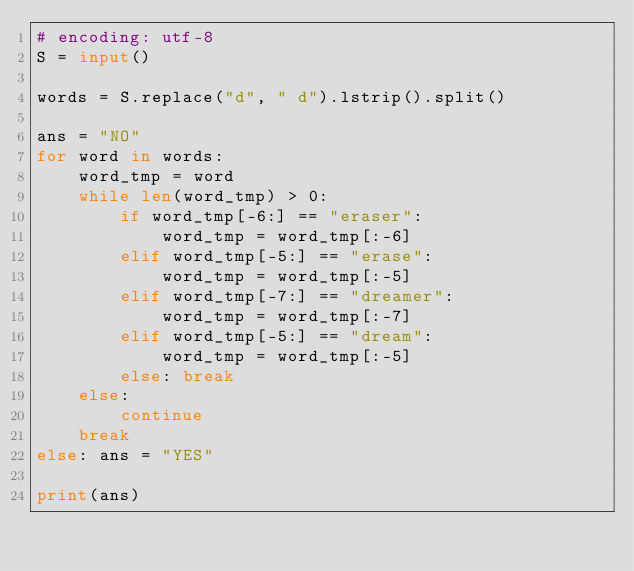Convert code to text. <code><loc_0><loc_0><loc_500><loc_500><_Python_># encoding: utf-8
S = input()

words = S.replace("d", " d").lstrip().split()

ans = "NO"
for word in words:
    word_tmp = word
    while len(word_tmp) > 0:
        if word_tmp[-6:] == "eraser":
            word_tmp = word_tmp[:-6]
        elif word_tmp[-5:] == "erase":
            word_tmp = word_tmp[:-5]
        elif word_tmp[-7:] == "dreamer":
            word_tmp = word_tmp[:-7]
        elif word_tmp[-5:] == "dream":
            word_tmp = word_tmp[:-5]
        else: break
    else:
        continue
    break
else: ans = "YES"

print(ans)</code> 